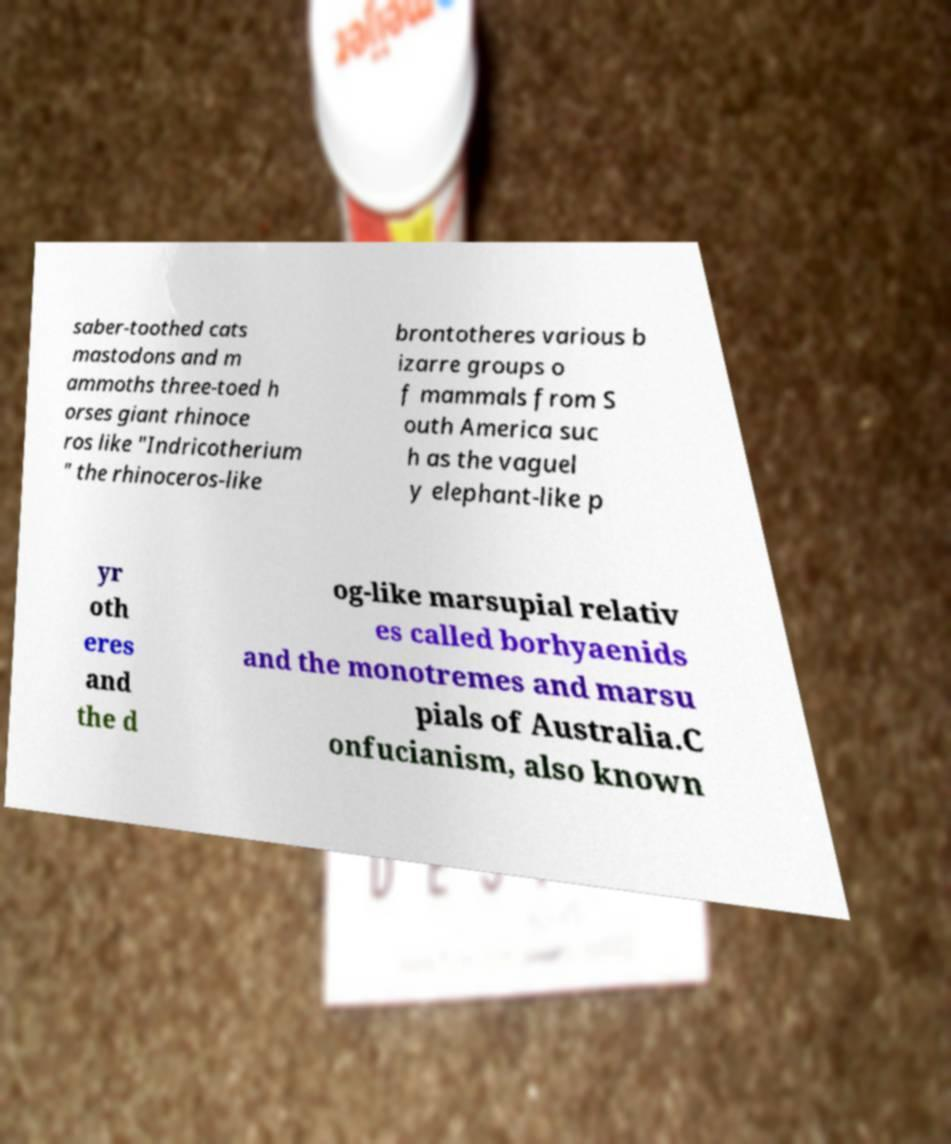Can you read and provide the text displayed in the image?This photo seems to have some interesting text. Can you extract and type it out for me? saber-toothed cats mastodons and m ammoths three-toed h orses giant rhinoce ros like "Indricotherium " the rhinoceros-like brontotheres various b izarre groups o f mammals from S outh America suc h as the vaguel y elephant-like p yr oth eres and the d og-like marsupial relativ es called borhyaenids and the monotremes and marsu pials of Australia.C onfucianism, also known 